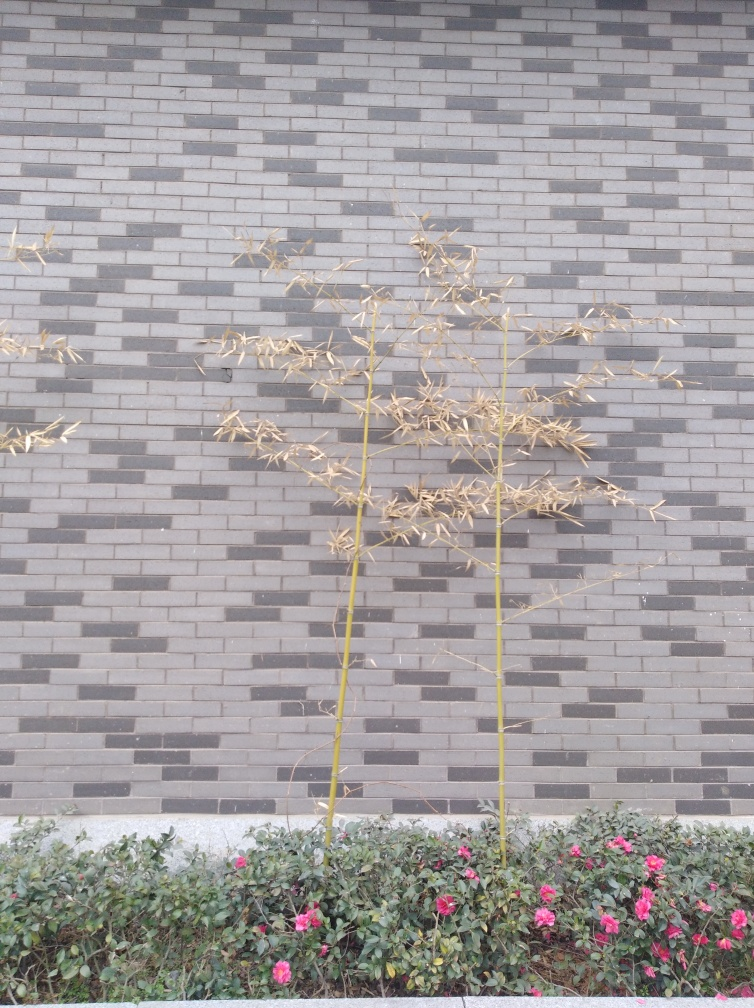What does the juxtaposition of the dried plants and blossoming flowers tell us? The juxtaposition of the dried plant and the blossoming flowers in the image highlights the cycle of life and the resilience of nature. It may indicate the presence of evergreen plants that continue to bloom despite colder temperatures or the adaptive qualities of some plant species to different seasons. Could it imply anything about the care given to the garden? Yes, it could suggest that certain areas of the garden receive more attention or are better suited for different plant species. This selective care or natural adaptation results in varied growth patterns and a diverse display of vegetation. 